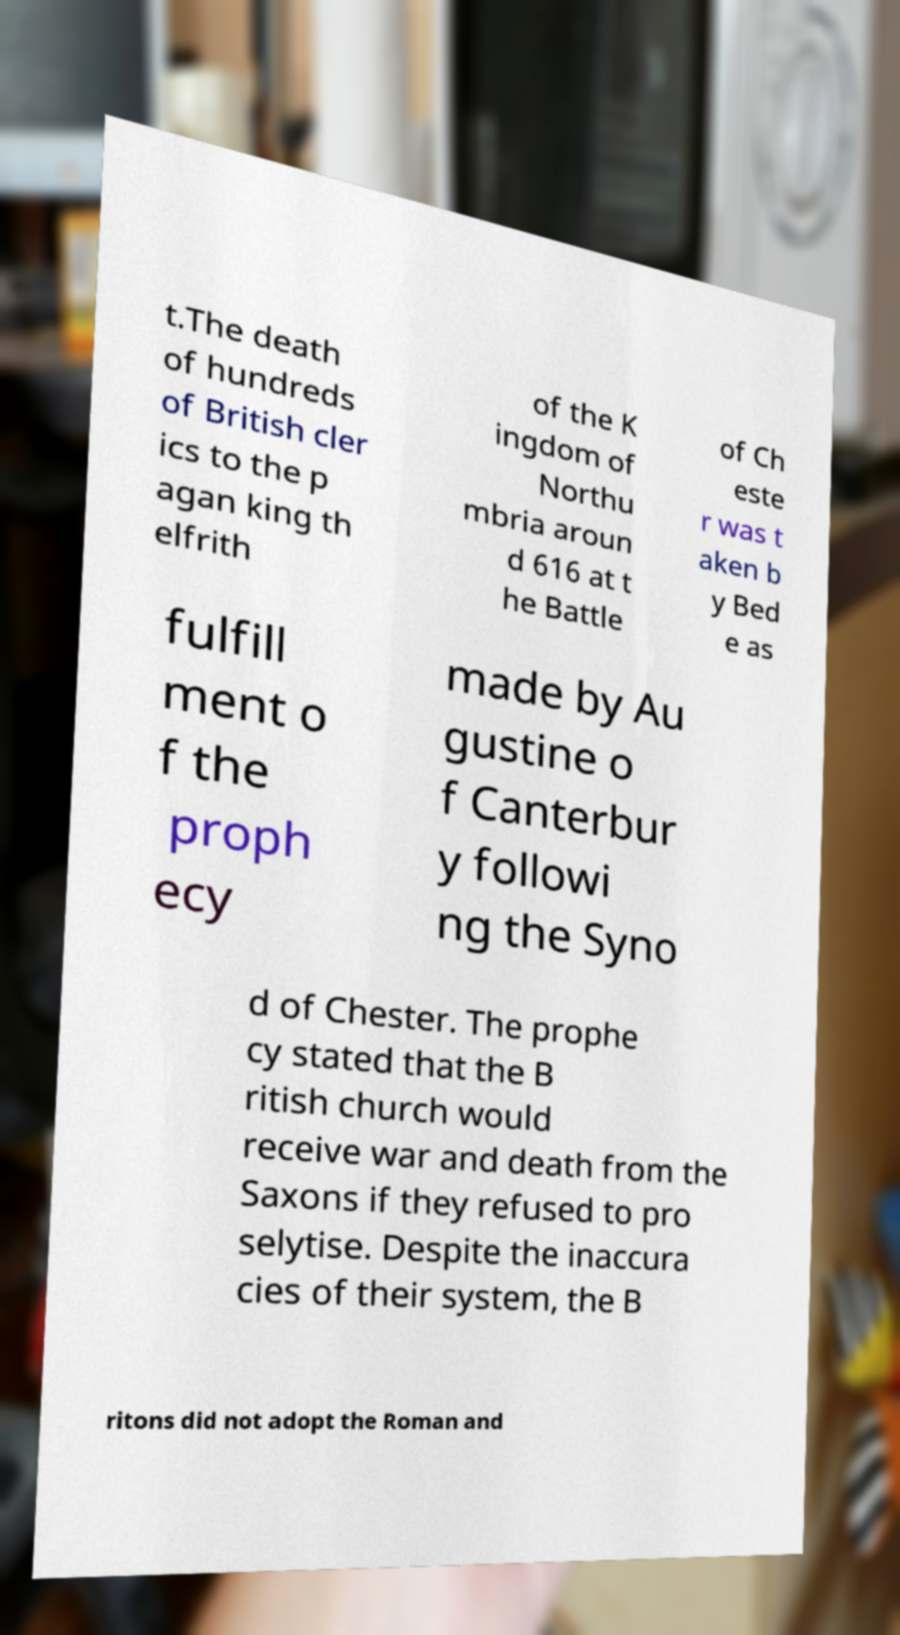Can you accurately transcribe the text from the provided image for me? t.The death of hundreds of British cler ics to the p agan king th elfrith of the K ingdom of Northu mbria aroun d 616 at t he Battle of Ch este r was t aken b y Bed e as fulfill ment o f the proph ecy made by Au gustine o f Canterbur y followi ng the Syno d of Chester. The prophe cy stated that the B ritish church would receive war and death from the Saxons if they refused to pro selytise. Despite the inaccura cies of their system, the B ritons did not adopt the Roman and 